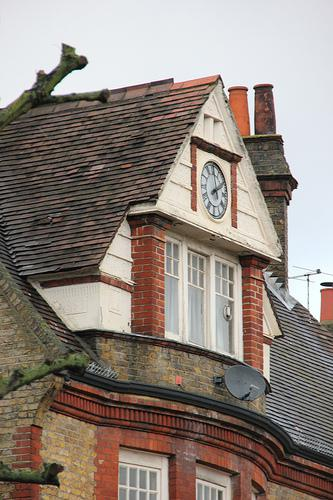Question: where is the clock?
Choices:
A. Below the windows.
B. On the desk.
C. On the wall.
D. Above the windows.
Answer with the letter. Answer: D Question: how many chimneys can be seen in the photo?
Choices:
A. 3.
B. 12.
C. 13.
D. 5.
Answer with the letter. Answer: A Question: what color are the bricks underneath the clock?
Choices:
A. Red.
B. Teal.
C. Purple.
D. Neon.
Answer with the letter. Answer: A Question: where is the antenna?
Choices:
A. On the building.
B. On the robot.
C. On the roof.
D. On the Television.
Answer with the letter. Answer: C 